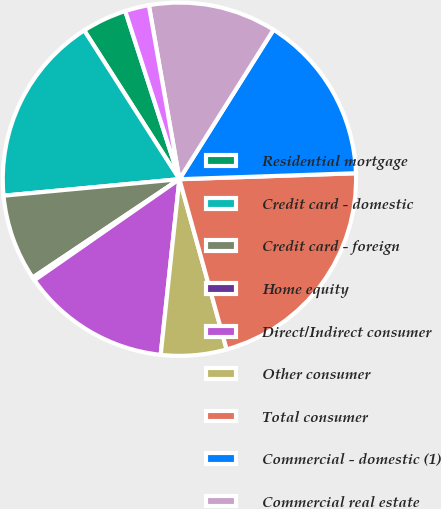<chart> <loc_0><loc_0><loc_500><loc_500><pie_chart><fcel>Residential mortgage<fcel>Credit card - domestic<fcel>Credit card - foreign<fcel>Home equity<fcel>Direct/Indirect consumer<fcel>Other consumer<fcel>Total consumer<fcel>Commercial - domestic (1)<fcel>Commercial real estate<fcel>Commercial lease financing<nl><fcel>4.1%<fcel>17.43%<fcel>7.91%<fcel>0.29%<fcel>13.62%<fcel>6.0%<fcel>21.23%<fcel>15.52%<fcel>11.71%<fcel>2.19%<nl></chart> 